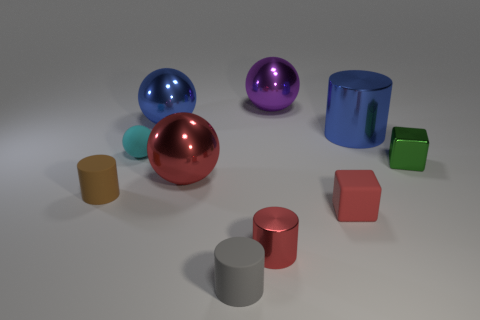What can you tell me about the texture and material of the objects? The shiny objects (blue, purple, and red spheres, and the large blue cylinder) seem to have a smooth metal texture. In contrast, the matte objects (various cylinders and cubes) appear to have a more diffuse, non-reflective surface indicating that they could be made of plastic or painted in a non-glossy finish. 